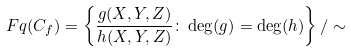Convert formula to latex. <formula><loc_0><loc_0><loc_500><loc_500>\ F q ( C _ { f } ) = \left \{ \frac { g ( X , Y , Z ) } { h ( X , Y , Z ) } \colon \deg ( g ) = \deg ( h ) \right \} / \sim</formula> 